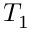<formula> <loc_0><loc_0><loc_500><loc_500>T _ { 1 }</formula> 